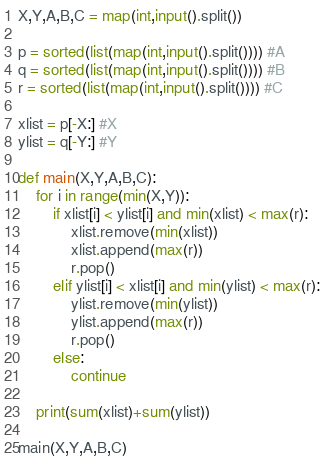<code> <loc_0><loc_0><loc_500><loc_500><_Python_>X,Y,A,B,C = map(int,input().split())

p = sorted(list(map(int,input().split()))) #A
q = sorted(list(map(int,input().split()))) #B
r = sorted(list(map(int,input().split()))) #C

xlist = p[-X:] #X
ylist = q[-Y:] #Y

def main(X,Y,A,B,C):
    for i in range(min(X,Y)):
        if xlist[i] < ylist[i] and min(xlist) < max(r):
            xlist.remove(min(xlist))
            xlist.append(max(r))
            r.pop()
        elif ylist[i] < xlist[i] and min(ylist) < max(r):
            ylist.remove(min(ylist))
            ylist.append(max(r))
            r.pop()
        else:
            continue
    
    print(sum(xlist)+sum(ylist))

main(X,Y,A,B,C)</code> 